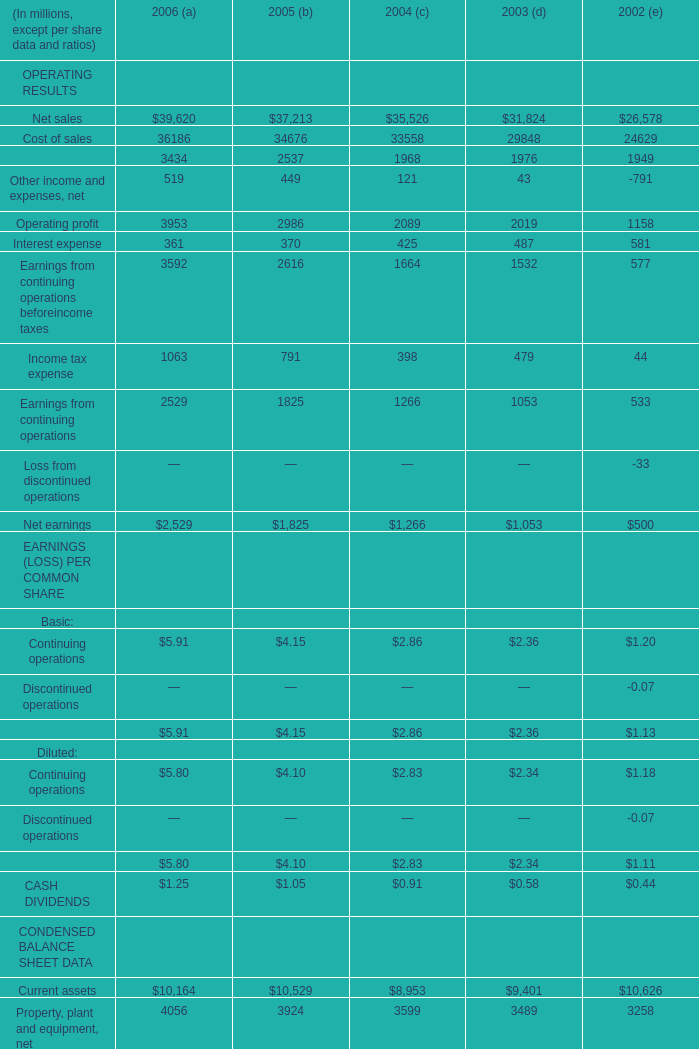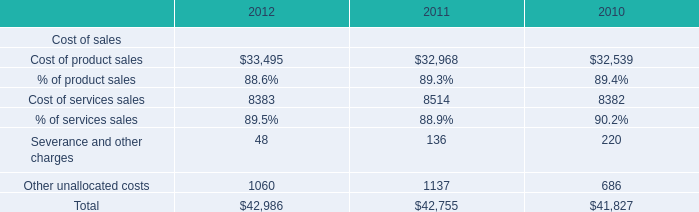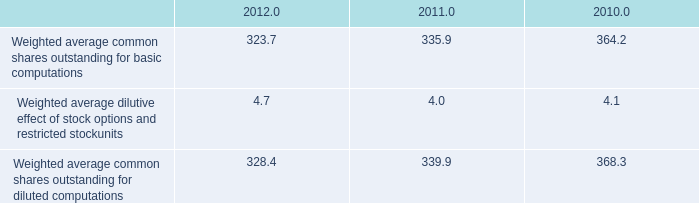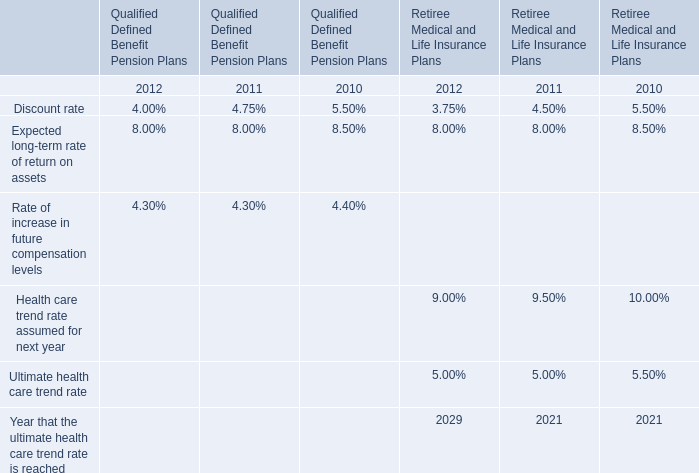What's the greatest value of OPERATING RESULTS in 2006? 
Answer: 39620. 